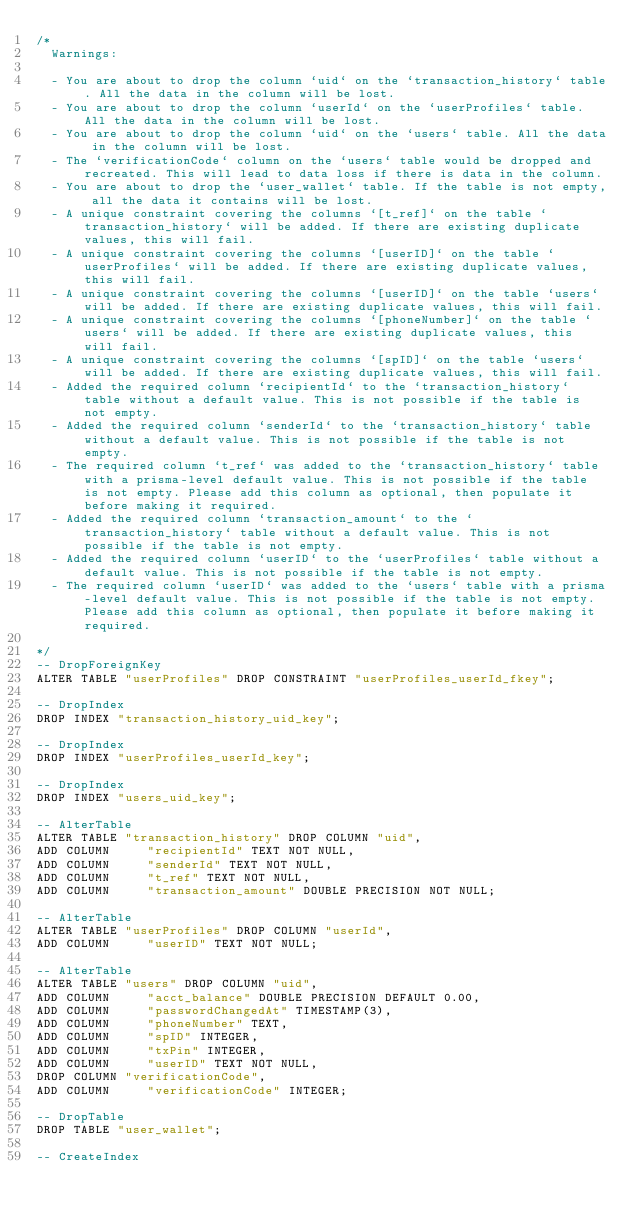<code> <loc_0><loc_0><loc_500><loc_500><_SQL_>/*
  Warnings:

  - You are about to drop the column `uid` on the `transaction_history` table. All the data in the column will be lost.
  - You are about to drop the column `userId` on the `userProfiles` table. All the data in the column will be lost.
  - You are about to drop the column `uid` on the `users` table. All the data in the column will be lost.
  - The `verificationCode` column on the `users` table would be dropped and recreated. This will lead to data loss if there is data in the column.
  - You are about to drop the `user_wallet` table. If the table is not empty, all the data it contains will be lost.
  - A unique constraint covering the columns `[t_ref]` on the table `transaction_history` will be added. If there are existing duplicate values, this will fail.
  - A unique constraint covering the columns `[userID]` on the table `userProfiles` will be added. If there are existing duplicate values, this will fail.
  - A unique constraint covering the columns `[userID]` on the table `users` will be added. If there are existing duplicate values, this will fail.
  - A unique constraint covering the columns `[phoneNumber]` on the table `users` will be added. If there are existing duplicate values, this will fail.
  - A unique constraint covering the columns `[spID]` on the table `users` will be added. If there are existing duplicate values, this will fail.
  - Added the required column `recipientId` to the `transaction_history` table without a default value. This is not possible if the table is not empty.
  - Added the required column `senderId` to the `transaction_history` table without a default value. This is not possible if the table is not empty.
  - The required column `t_ref` was added to the `transaction_history` table with a prisma-level default value. This is not possible if the table is not empty. Please add this column as optional, then populate it before making it required.
  - Added the required column `transaction_amount` to the `transaction_history` table without a default value. This is not possible if the table is not empty.
  - Added the required column `userID` to the `userProfiles` table without a default value. This is not possible if the table is not empty.
  - The required column `userID` was added to the `users` table with a prisma-level default value. This is not possible if the table is not empty. Please add this column as optional, then populate it before making it required.

*/
-- DropForeignKey
ALTER TABLE "userProfiles" DROP CONSTRAINT "userProfiles_userId_fkey";

-- DropIndex
DROP INDEX "transaction_history_uid_key";

-- DropIndex
DROP INDEX "userProfiles_userId_key";

-- DropIndex
DROP INDEX "users_uid_key";

-- AlterTable
ALTER TABLE "transaction_history" DROP COLUMN "uid",
ADD COLUMN     "recipientId" TEXT NOT NULL,
ADD COLUMN     "senderId" TEXT NOT NULL,
ADD COLUMN     "t_ref" TEXT NOT NULL,
ADD COLUMN     "transaction_amount" DOUBLE PRECISION NOT NULL;

-- AlterTable
ALTER TABLE "userProfiles" DROP COLUMN "userId",
ADD COLUMN     "userID" TEXT NOT NULL;

-- AlterTable
ALTER TABLE "users" DROP COLUMN "uid",
ADD COLUMN     "acct_balance" DOUBLE PRECISION DEFAULT 0.00,
ADD COLUMN     "passwordChangedAt" TIMESTAMP(3),
ADD COLUMN     "phoneNumber" TEXT,
ADD COLUMN     "spID" INTEGER,
ADD COLUMN     "txPin" INTEGER,
ADD COLUMN     "userID" TEXT NOT NULL,
DROP COLUMN "verificationCode",
ADD COLUMN     "verificationCode" INTEGER;

-- DropTable
DROP TABLE "user_wallet";

-- CreateIndex</code> 